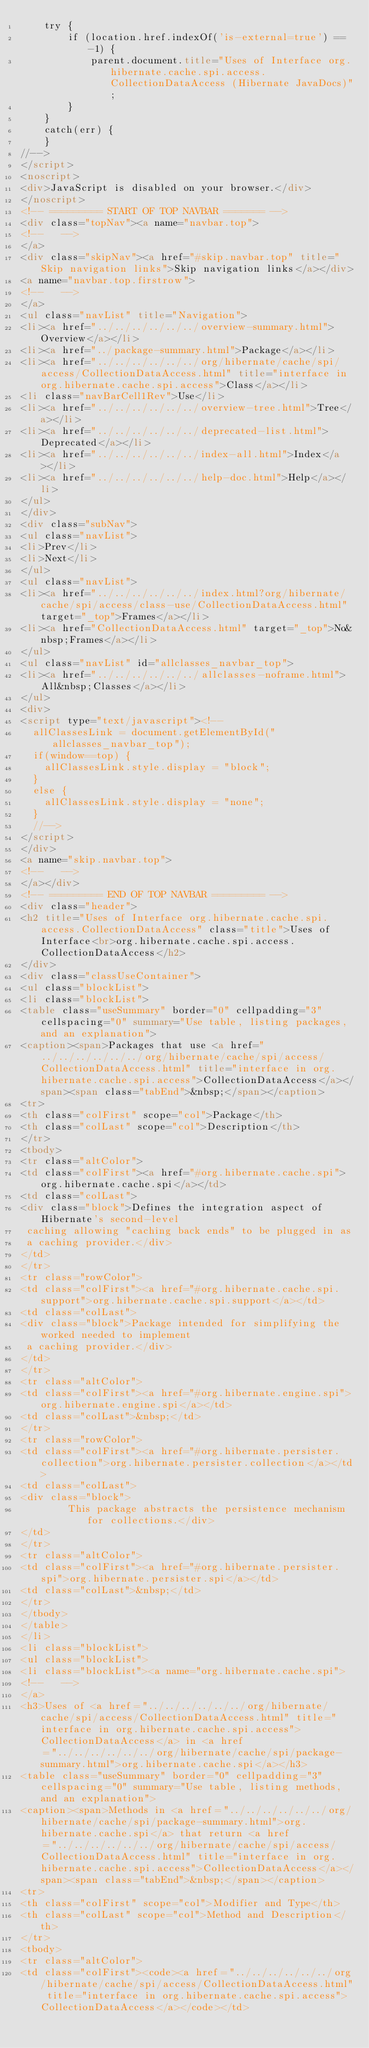Convert code to text. <code><loc_0><loc_0><loc_500><loc_500><_HTML_>    try {
        if (location.href.indexOf('is-external=true') == -1) {
            parent.document.title="Uses of Interface org.hibernate.cache.spi.access.CollectionDataAccess (Hibernate JavaDocs)";
        }
    }
    catch(err) {
    }
//-->
</script>
<noscript>
<div>JavaScript is disabled on your browser.</div>
</noscript>
<!-- ========= START OF TOP NAVBAR ======= -->
<div class="topNav"><a name="navbar.top">
<!--   -->
</a>
<div class="skipNav"><a href="#skip.navbar.top" title="Skip navigation links">Skip navigation links</a></div>
<a name="navbar.top.firstrow">
<!--   -->
</a>
<ul class="navList" title="Navigation">
<li><a href="../../../../../../overview-summary.html">Overview</a></li>
<li><a href="../package-summary.html">Package</a></li>
<li><a href="../../../../../../org/hibernate/cache/spi/access/CollectionDataAccess.html" title="interface in org.hibernate.cache.spi.access">Class</a></li>
<li class="navBarCell1Rev">Use</li>
<li><a href="../../../../../../overview-tree.html">Tree</a></li>
<li><a href="../../../../../../deprecated-list.html">Deprecated</a></li>
<li><a href="../../../../../../index-all.html">Index</a></li>
<li><a href="../../../../../../help-doc.html">Help</a></li>
</ul>
</div>
<div class="subNav">
<ul class="navList">
<li>Prev</li>
<li>Next</li>
</ul>
<ul class="navList">
<li><a href="../../../../../../index.html?org/hibernate/cache/spi/access/class-use/CollectionDataAccess.html" target="_top">Frames</a></li>
<li><a href="CollectionDataAccess.html" target="_top">No&nbsp;Frames</a></li>
</ul>
<ul class="navList" id="allclasses_navbar_top">
<li><a href="../../../../../../allclasses-noframe.html">All&nbsp;Classes</a></li>
</ul>
<div>
<script type="text/javascript"><!--
  allClassesLink = document.getElementById("allclasses_navbar_top");
  if(window==top) {
    allClassesLink.style.display = "block";
  }
  else {
    allClassesLink.style.display = "none";
  }
  //-->
</script>
</div>
<a name="skip.navbar.top">
<!--   -->
</a></div>
<!-- ========= END OF TOP NAVBAR ========= -->
<div class="header">
<h2 title="Uses of Interface org.hibernate.cache.spi.access.CollectionDataAccess" class="title">Uses of Interface<br>org.hibernate.cache.spi.access.CollectionDataAccess</h2>
</div>
<div class="classUseContainer">
<ul class="blockList">
<li class="blockList">
<table class="useSummary" border="0" cellpadding="3" cellspacing="0" summary="Use table, listing packages, and an explanation">
<caption><span>Packages that use <a href="../../../../../../org/hibernate/cache/spi/access/CollectionDataAccess.html" title="interface in org.hibernate.cache.spi.access">CollectionDataAccess</a></span><span class="tabEnd">&nbsp;</span></caption>
<tr>
<th class="colFirst" scope="col">Package</th>
<th class="colLast" scope="col">Description</th>
</tr>
<tbody>
<tr class="altColor">
<td class="colFirst"><a href="#org.hibernate.cache.spi">org.hibernate.cache.spi</a></td>
<td class="colLast">
<div class="block">Defines the integration aspect of Hibernate's second-level
 caching allowing "caching back ends" to be plugged in as
 a caching provider.</div>
</td>
</tr>
<tr class="rowColor">
<td class="colFirst"><a href="#org.hibernate.cache.spi.support">org.hibernate.cache.spi.support</a></td>
<td class="colLast">
<div class="block">Package intended for simplifying the worked needed to implement
 a caching provider.</div>
</td>
</tr>
<tr class="altColor">
<td class="colFirst"><a href="#org.hibernate.engine.spi">org.hibernate.engine.spi</a></td>
<td class="colLast">&nbsp;</td>
</tr>
<tr class="rowColor">
<td class="colFirst"><a href="#org.hibernate.persister.collection">org.hibernate.persister.collection</a></td>
<td class="colLast">
<div class="block">
        This package abstracts the persistence mechanism for collections.</div>
</td>
</tr>
<tr class="altColor">
<td class="colFirst"><a href="#org.hibernate.persister.spi">org.hibernate.persister.spi</a></td>
<td class="colLast">&nbsp;</td>
</tr>
</tbody>
</table>
</li>
<li class="blockList">
<ul class="blockList">
<li class="blockList"><a name="org.hibernate.cache.spi">
<!--   -->
</a>
<h3>Uses of <a href="../../../../../../org/hibernate/cache/spi/access/CollectionDataAccess.html" title="interface in org.hibernate.cache.spi.access">CollectionDataAccess</a> in <a href="../../../../../../org/hibernate/cache/spi/package-summary.html">org.hibernate.cache.spi</a></h3>
<table class="useSummary" border="0" cellpadding="3" cellspacing="0" summary="Use table, listing methods, and an explanation">
<caption><span>Methods in <a href="../../../../../../org/hibernate/cache/spi/package-summary.html">org.hibernate.cache.spi</a> that return <a href="../../../../../../org/hibernate/cache/spi/access/CollectionDataAccess.html" title="interface in org.hibernate.cache.spi.access">CollectionDataAccess</a></span><span class="tabEnd">&nbsp;</span></caption>
<tr>
<th class="colFirst" scope="col">Modifier and Type</th>
<th class="colLast" scope="col">Method and Description</th>
</tr>
<tbody>
<tr class="altColor">
<td class="colFirst"><code><a href="../../../../../../org/hibernate/cache/spi/access/CollectionDataAccess.html" title="interface in org.hibernate.cache.spi.access">CollectionDataAccess</a></code></td></code> 